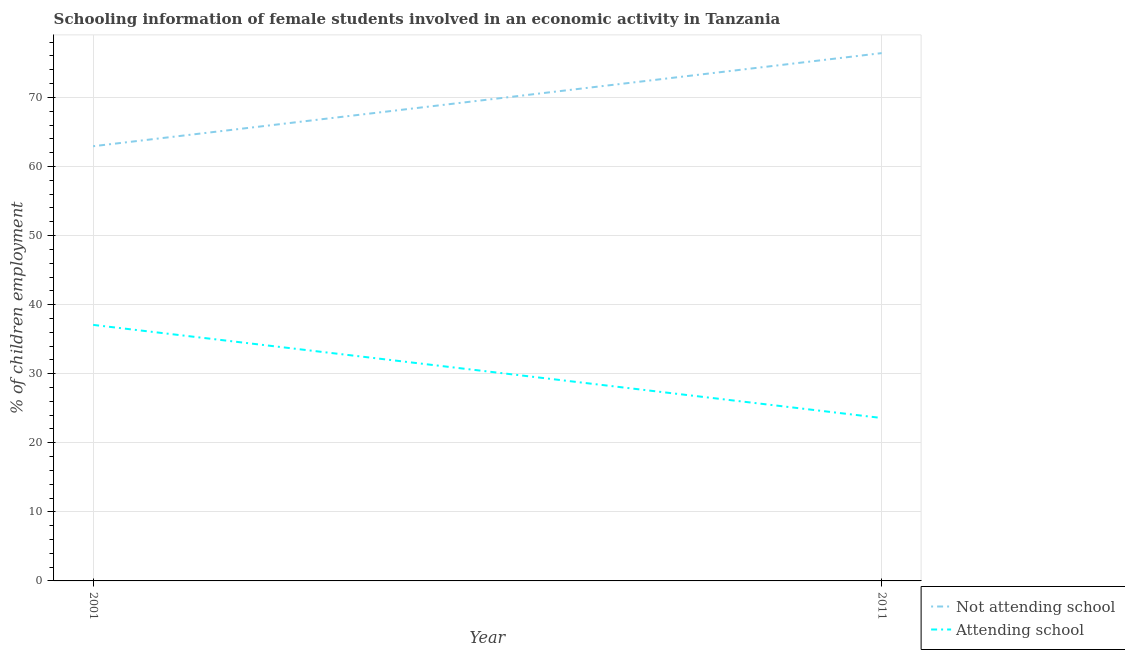How many different coloured lines are there?
Your answer should be compact. 2. Does the line corresponding to percentage of employed females who are attending school intersect with the line corresponding to percentage of employed females who are not attending school?
Your response must be concise. No. Is the number of lines equal to the number of legend labels?
Your response must be concise. Yes. What is the percentage of employed females who are attending school in 2011?
Offer a terse response. 23.59. Across all years, what is the maximum percentage of employed females who are not attending school?
Your answer should be compact. 76.41. Across all years, what is the minimum percentage of employed females who are not attending school?
Ensure brevity in your answer.  62.93. In which year was the percentage of employed females who are attending school maximum?
Your response must be concise. 2001. What is the total percentage of employed females who are attending school in the graph?
Your answer should be very brief. 60.65. What is the difference between the percentage of employed females who are not attending school in 2001 and that in 2011?
Give a very brief answer. -13.48. What is the difference between the percentage of employed females who are not attending school in 2011 and the percentage of employed females who are attending school in 2001?
Make the answer very short. 39.35. What is the average percentage of employed females who are not attending school per year?
Offer a very short reply. 69.67. In the year 2001, what is the difference between the percentage of employed females who are attending school and percentage of employed females who are not attending school?
Your response must be concise. -25.87. In how many years, is the percentage of employed females who are not attending school greater than 66 %?
Give a very brief answer. 1. What is the ratio of the percentage of employed females who are attending school in 2001 to that in 2011?
Your response must be concise. 1.57. Is the percentage of employed females who are attending school in 2001 less than that in 2011?
Your response must be concise. No. In how many years, is the percentage of employed females who are attending school greater than the average percentage of employed females who are attending school taken over all years?
Offer a terse response. 1. Is the percentage of employed females who are attending school strictly greater than the percentage of employed females who are not attending school over the years?
Provide a short and direct response. No. Is the percentage of employed females who are attending school strictly less than the percentage of employed females who are not attending school over the years?
Offer a terse response. Yes. How many years are there in the graph?
Provide a succinct answer. 2. What is the difference between two consecutive major ticks on the Y-axis?
Give a very brief answer. 10. Where does the legend appear in the graph?
Your answer should be compact. Bottom right. What is the title of the graph?
Your response must be concise. Schooling information of female students involved in an economic activity in Tanzania. What is the label or title of the Y-axis?
Make the answer very short. % of children employment. What is the % of children employment of Not attending school in 2001?
Provide a succinct answer. 62.93. What is the % of children employment in Attending school in 2001?
Provide a succinct answer. 37.07. What is the % of children employment in Not attending school in 2011?
Provide a succinct answer. 76.41. What is the % of children employment in Attending school in 2011?
Provide a succinct answer. 23.59. Across all years, what is the maximum % of children employment in Not attending school?
Give a very brief answer. 76.41. Across all years, what is the maximum % of children employment of Attending school?
Your answer should be compact. 37.07. Across all years, what is the minimum % of children employment of Not attending school?
Give a very brief answer. 62.93. Across all years, what is the minimum % of children employment of Attending school?
Make the answer very short. 23.59. What is the total % of children employment of Not attending school in the graph?
Provide a short and direct response. 139.35. What is the total % of children employment in Attending school in the graph?
Provide a succinct answer. 60.65. What is the difference between the % of children employment in Not attending school in 2001 and that in 2011?
Provide a short and direct response. -13.48. What is the difference between the % of children employment in Attending school in 2001 and that in 2011?
Offer a very short reply. 13.48. What is the difference between the % of children employment in Not attending school in 2001 and the % of children employment in Attending school in 2011?
Your answer should be compact. 39.35. What is the average % of children employment in Not attending school per year?
Give a very brief answer. 69.67. What is the average % of children employment of Attending school per year?
Your answer should be very brief. 30.33. In the year 2001, what is the difference between the % of children employment of Not attending school and % of children employment of Attending school?
Keep it short and to the point. 25.87. In the year 2011, what is the difference between the % of children employment of Not attending school and % of children employment of Attending school?
Your response must be concise. 52.83. What is the ratio of the % of children employment of Not attending school in 2001 to that in 2011?
Your response must be concise. 0.82. What is the ratio of the % of children employment of Attending school in 2001 to that in 2011?
Provide a short and direct response. 1.57. What is the difference between the highest and the second highest % of children employment of Not attending school?
Your response must be concise. 13.48. What is the difference between the highest and the second highest % of children employment of Attending school?
Offer a terse response. 13.48. What is the difference between the highest and the lowest % of children employment in Not attending school?
Offer a terse response. 13.48. What is the difference between the highest and the lowest % of children employment of Attending school?
Offer a terse response. 13.48. 